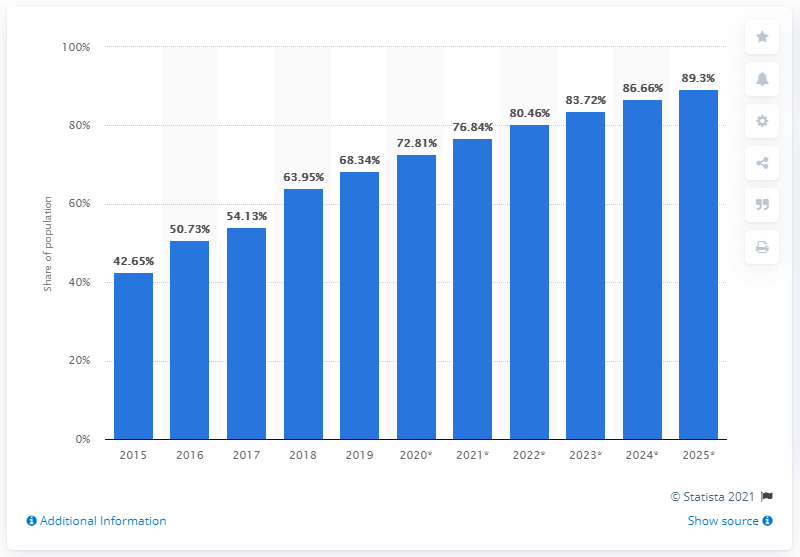List a handful of essential elements in this visual. As of 2019, the internet user penetration rate in Indonesia was 68.34%. 